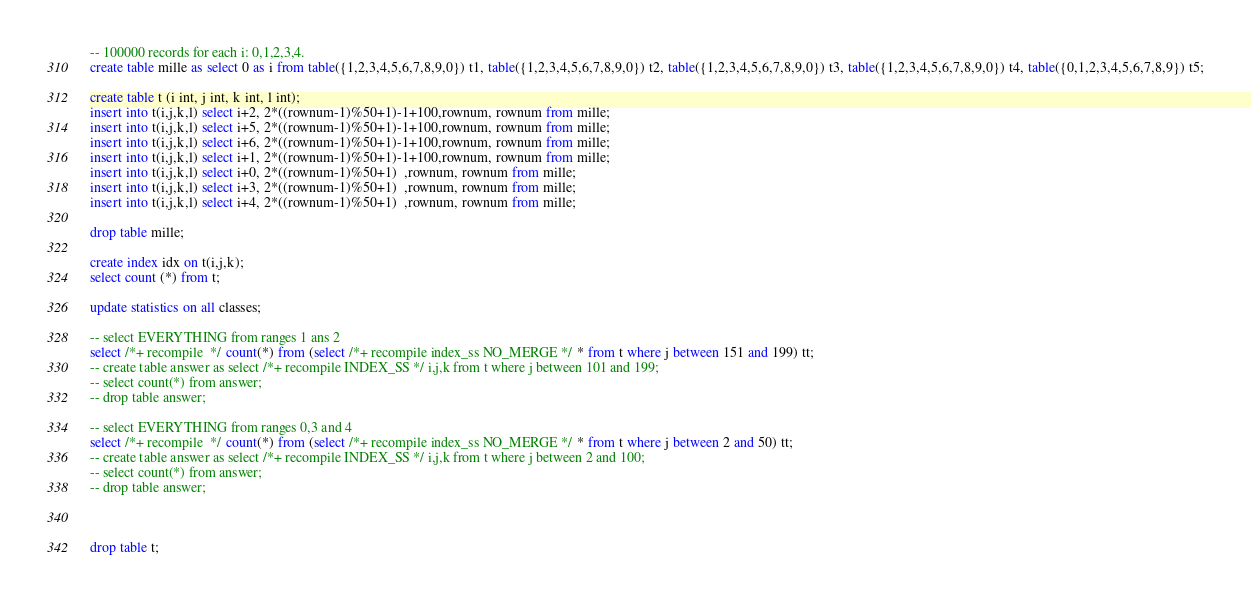<code> <loc_0><loc_0><loc_500><loc_500><_SQL_>-- 100000 records for each i: 0,1,2,3,4.
create table mille as select 0 as i from table({1,2,3,4,5,6,7,8,9,0}) t1, table({1,2,3,4,5,6,7,8,9,0}) t2, table({1,2,3,4,5,6,7,8,9,0}) t3, table({1,2,3,4,5,6,7,8,9,0}) t4, table({0,1,2,3,4,5,6,7,8,9}) t5;

create table t (i int, j int, k int, l int);
insert into t(i,j,k,l) select i+2, 2*((rownum-1)%50+1)-1+100,rownum, rownum from mille;
insert into t(i,j,k,l) select i+5, 2*((rownum-1)%50+1)-1+100,rownum, rownum from mille;
insert into t(i,j,k,l) select i+6, 2*((rownum-1)%50+1)-1+100,rownum, rownum from mille;
insert into t(i,j,k,l) select i+1, 2*((rownum-1)%50+1)-1+100,rownum, rownum from mille;
insert into t(i,j,k,l) select i+0, 2*((rownum-1)%50+1)  ,rownum, rownum from mille;
insert into t(i,j,k,l) select i+3, 2*((rownum-1)%50+1)  ,rownum, rownum from mille;
insert into t(i,j,k,l) select i+4, 2*((rownum-1)%50+1)  ,rownum, rownum from mille;

drop table mille;

create index idx on t(i,j,k);
select count (*) from t;

update statistics on all classes;

-- select EVERYTHING from ranges 1 ans 2
select /*+ recompile  */ count(*) from (select /*+ recompile index_ss NO_MERGE */ * from t where j between 151 and 199) tt;
-- create table answer as select /*+ recompile INDEX_SS */ i,j,k from t where j between 101 and 199;
-- select count(*) from answer;
-- drop table answer;

-- select EVERYTHING from ranges 0,3 and 4
select /*+ recompile  */ count(*) from (select /*+ recompile index_ss NO_MERGE */ * from t where j between 2 and 50) tt;
-- create table answer as select /*+ recompile INDEX_SS */ i,j,k from t where j between 2 and 100;
-- select count(*) from answer;
-- drop table answer;



drop table t;
</code> 